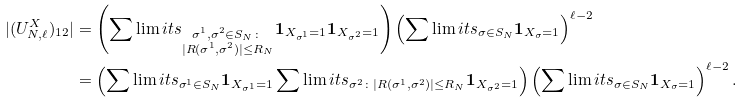<formula> <loc_0><loc_0><loc_500><loc_500>| ( U _ { N , \ell } ^ { X } ) _ { 1 2 } | & = \left ( \sum \lim i t s _ { \substack { \sigma ^ { 1 } , \sigma ^ { 2 } \in S _ { N } \colon \\ | R ( \sigma ^ { 1 } , \sigma ^ { 2 } ) | \leq R _ { N } } } { \mathbf 1 } _ { X _ { \sigma ^ { 1 } } = 1 } { \mathbf 1 } _ { X _ { \sigma ^ { 2 } } = 1 } \right ) \left ( \sum \lim i t s _ { \sigma \in S _ { N } } { \mathbf 1 } _ { X _ { \sigma } = 1 } \right ) ^ { \ell - 2 } \\ & = \left ( \sum \lim i t s _ { \sigma ^ { 1 } \in S _ { N } } { \mathbf 1 } _ { X _ { \sigma ^ { 1 } } = 1 } \sum \lim i t s _ { \sigma ^ { 2 } \colon | R ( \sigma ^ { 1 } , \sigma ^ { 2 } ) | \leq R _ { N } } { \mathbf 1 } _ { X _ { \sigma ^ { 2 } } = 1 } \right ) \left ( \sum \lim i t s _ { \sigma \in S _ { N } } { \mathbf 1 } _ { X _ { \sigma } = 1 } \right ) ^ { \ell - 2 } .</formula> 